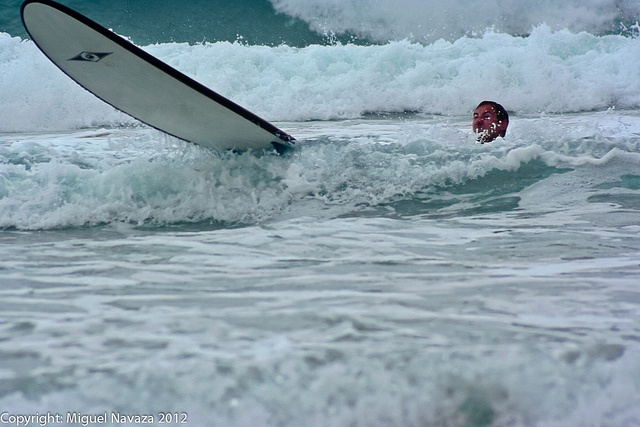Describe the objects in this image and their specific colors. I can see surfboard in teal, gray, black, and purple tones and people in teal, black, maroon, gray, and purple tones in this image. 